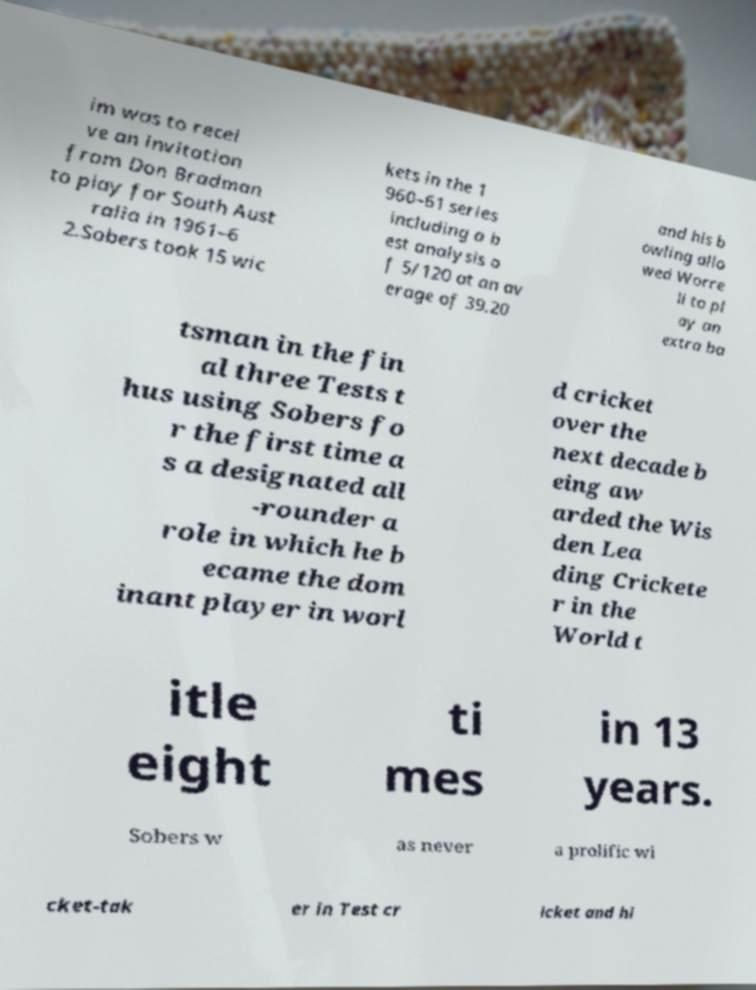Please identify and transcribe the text found in this image. im was to recei ve an invitation from Don Bradman to play for South Aust ralia in 1961–6 2.Sobers took 15 wic kets in the 1 960–61 series including a b est analysis o f 5/120 at an av erage of 39.20 and his b owling allo wed Worre ll to pl ay an extra ba tsman in the fin al three Tests t hus using Sobers fo r the first time a s a designated all -rounder a role in which he b ecame the dom inant player in worl d cricket over the next decade b eing aw arded the Wis den Lea ding Crickete r in the World t itle eight ti mes in 13 years. Sobers w as never a prolific wi cket-tak er in Test cr icket and hi 